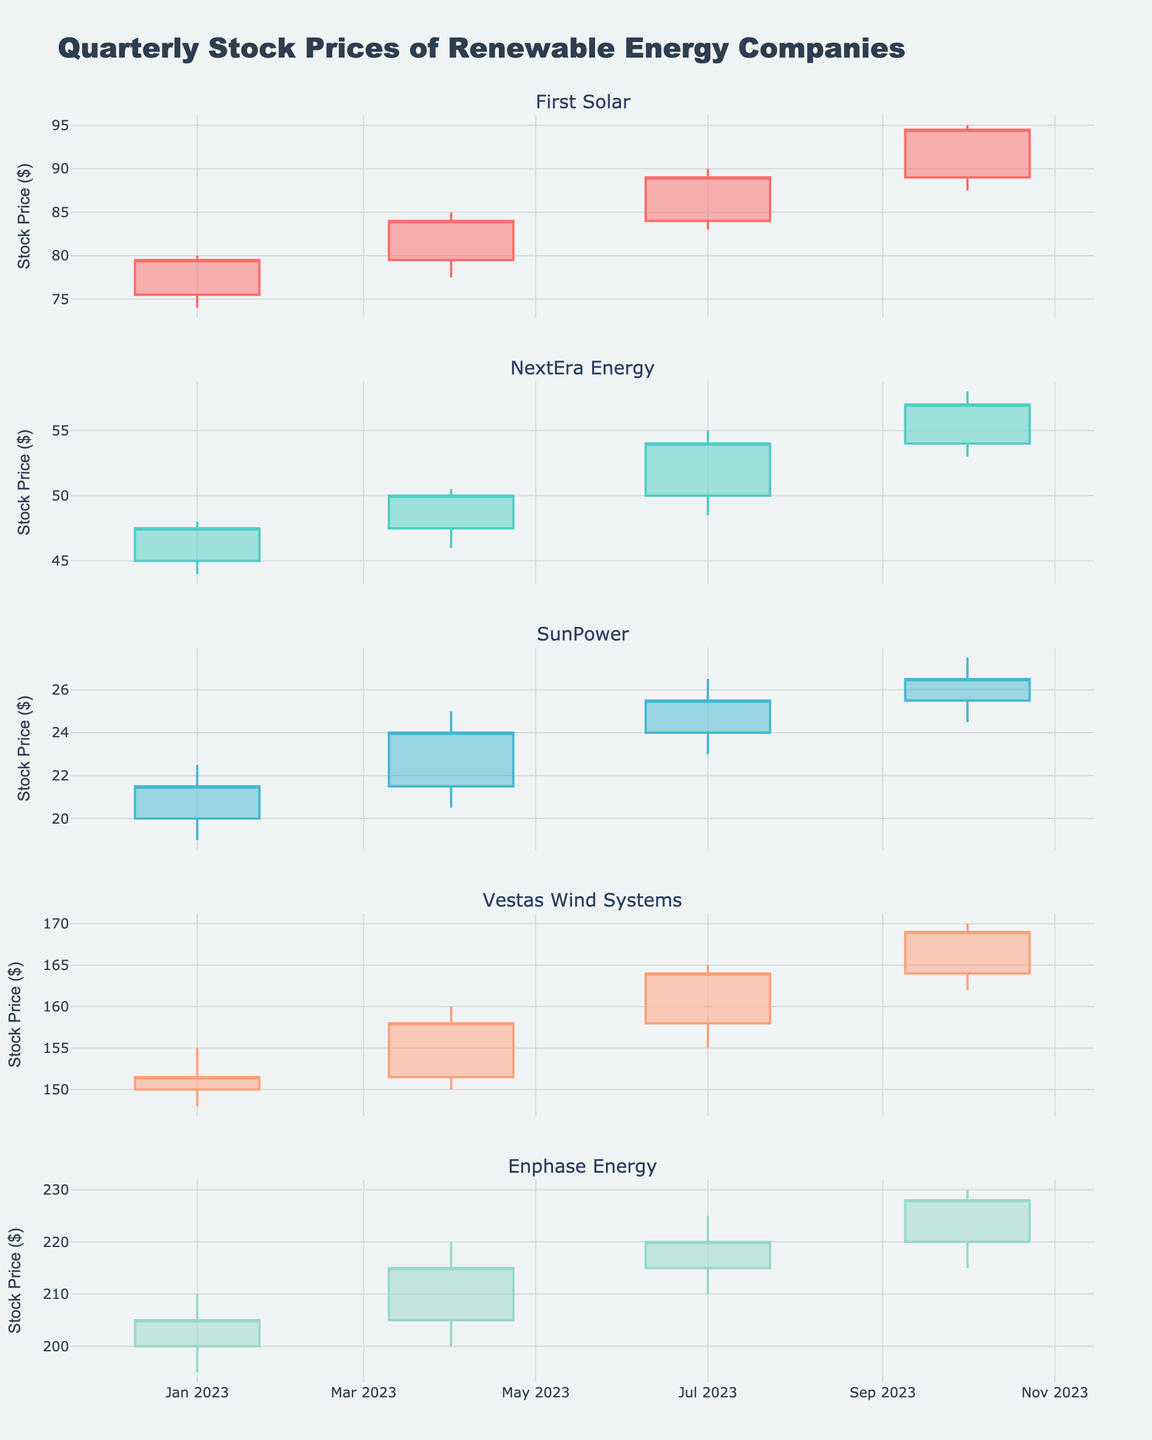What is the overall title of the plot? The title is typically located at the top of the plot and is distinctively bold and large in size. Here, it clearly states the main purpose of the plot.
Answer: Quarterly Stock Prices of Renewable Energy Companies Which company has the highest stock price at the end of October 2023? To identify this, look at the closing prices in the candlestick plot for the end of October 2023 for each company. The highest value should be noted.
Answer: Enphase Energy How did NextEra Energy's stock price change between April 2023 and July 2023? Review NextEra Energy’s candlestick for the two specified dates and compare the closing prices. Calculate the difference.
Answer: Increased by 4.00 (from 50.00 to 54.00) Which company had a larger percentage increase in stock price from January 2023 to October 2023, First Solar or Vestas Wind Systems? Calculate the initial and final stock prices for both companies. Use the formula ((final - initial) / initial) * 100 to find the percentage increase for each company and compare.
Answer: First Solar What is the stock price range (high - low) for SunPower in July 2023? Locate the candlestick for SunPower in July 2023 and subtract the low price from the high price.
Answer: 3.50 (26.50 - 23.00) Which company showed consistently increasing stock prices each quarter, and by approximately how much did the stock price increase overall for this company? Look at all companies and track their quarterly closing prices. Identify the company with no decreasing quarters and calculate the total increase from the first to the last quarter.
Answer: First Solar, increased by 15.00 (94.50 - 79.50) In which quarter did Enphase Energy see the highest stock price volatility, and how do you determine that? Examine each candlestick of Enphase Energy. The longest candlestick, which shows the largest difference between high and low prices, indicates the highest volatility.
Answer: April 2023, volatility of 20.00 (220.00 - 200.00) Compare the closing stock price of Vestas Wind Systems in January and October of 2023. Was it higher in October, and by how much? Look at the closing prices for Vestas Wind Systems in January and October 2023 and calculate the difference.
Answer: Higher by 17.50 (169.00 - 151.50) What is the average closing price for all companies in the last quarter of 2023? Sum the closing prices of all companies in October 2023 and divide by the number of companies.
Answer: (94.50 + 57.00 + 26.50 + 169.00 + 228.00) / 5 = 115.80 